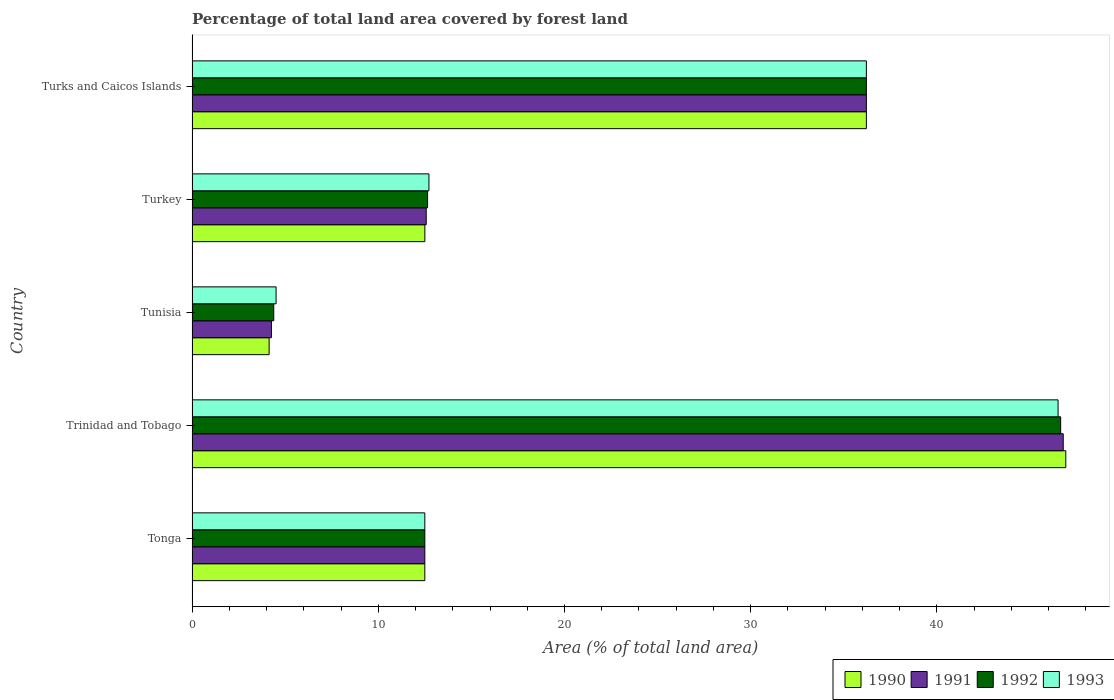How many groups of bars are there?
Give a very brief answer. 5. Are the number of bars per tick equal to the number of legend labels?
Your answer should be very brief. Yes. How many bars are there on the 4th tick from the top?
Keep it short and to the point. 4. What is the label of the 4th group of bars from the top?
Your answer should be compact. Trinidad and Tobago. Across all countries, what is the maximum percentage of forest land in 1992?
Your answer should be very brief. 46.64. Across all countries, what is the minimum percentage of forest land in 1993?
Provide a succinct answer. 4.51. In which country was the percentage of forest land in 1992 maximum?
Keep it short and to the point. Trinidad and Tobago. In which country was the percentage of forest land in 1990 minimum?
Your response must be concise. Tunisia. What is the total percentage of forest land in 1993 in the graph?
Give a very brief answer. 112.45. What is the difference between the percentage of forest land in 1993 in Tunisia and that in Turks and Caicos Islands?
Your answer should be very brief. -31.7. What is the difference between the percentage of forest land in 1991 in Tunisia and the percentage of forest land in 1992 in Tonga?
Your answer should be very brief. -8.24. What is the average percentage of forest land in 1991 per country?
Offer a terse response. 22.47. What is the difference between the percentage of forest land in 1992 and percentage of forest land in 1993 in Turkey?
Give a very brief answer. -0.07. In how many countries, is the percentage of forest land in 1990 greater than 18 %?
Offer a very short reply. 2. What is the ratio of the percentage of forest land in 1991 in Tunisia to that in Turkey?
Provide a short and direct response. 0.34. What is the difference between the highest and the second highest percentage of forest land in 1992?
Give a very brief answer. 10.43. What is the difference between the highest and the lowest percentage of forest land in 1993?
Provide a short and direct response. 41.99. In how many countries, is the percentage of forest land in 1992 greater than the average percentage of forest land in 1992 taken over all countries?
Offer a terse response. 2. Is the sum of the percentage of forest land in 1990 in Tunisia and Turks and Caicos Islands greater than the maximum percentage of forest land in 1992 across all countries?
Make the answer very short. No. Is it the case that in every country, the sum of the percentage of forest land in 1993 and percentage of forest land in 1990 is greater than the sum of percentage of forest land in 1991 and percentage of forest land in 1992?
Offer a very short reply. No. Is it the case that in every country, the sum of the percentage of forest land in 1990 and percentage of forest land in 1992 is greater than the percentage of forest land in 1991?
Your answer should be very brief. Yes. How many countries are there in the graph?
Your answer should be very brief. 5. What is the difference between two consecutive major ticks on the X-axis?
Offer a terse response. 10. Are the values on the major ticks of X-axis written in scientific E-notation?
Ensure brevity in your answer.  No. Does the graph contain grids?
Your response must be concise. No. Where does the legend appear in the graph?
Your answer should be very brief. Bottom right. How many legend labels are there?
Make the answer very short. 4. How are the legend labels stacked?
Make the answer very short. Horizontal. What is the title of the graph?
Offer a very short reply. Percentage of total land area covered by forest land. What is the label or title of the X-axis?
Keep it short and to the point. Area (% of total land area). What is the label or title of the Y-axis?
Ensure brevity in your answer.  Country. What is the Area (% of total land area) in 1990 in Tonga?
Offer a terse response. 12.5. What is the Area (% of total land area) in 1991 in Tonga?
Make the answer very short. 12.5. What is the Area (% of total land area) of 1992 in Tonga?
Make the answer very short. 12.5. What is the Area (% of total land area) in 1990 in Trinidad and Tobago?
Offer a terse response. 46.92. What is the Area (% of total land area) of 1991 in Trinidad and Tobago?
Keep it short and to the point. 46.78. What is the Area (% of total land area) of 1992 in Trinidad and Tobago?
Provide a short and direct response. 46.64. What is the Area (% of total land area) of 1993 in Trinidad and Tobago?
Provide a short and direct response. 46.5. What is the Area (% of total land area) of 1990 in Tunisia?
Offer a terse response. 4.14. What is the Area (% of total land area) in 1991 in Tunisia?
Give a very brief answer. 4.26. What is the Area (% of total land area) in 1992 in Tunisia?
Provide a short and direct response. 4.39. What is the Area (% of total land area) of 1993 in Tunisia?
Provide a short and direct response. 4.51. What is the Area (% of total land area) of 1990 in Turkey?
Provide a short and direct response. 12.5. What is the Area (% of total land area) of 1991 in Turkey?
Your answer should be compact. 12.58. What is the Area (% of total land area) in 1992 in Turkey?
Your response must be concise. 12.65. What is the Area (% of total land area) in 1993 in Turkey?
Keep it short and to the point. 12.72. What is the Area (% of total land area) in 1990 in Turks and Caicos Islands?
Offer a terse response. 36.21. What is the Area (% of total land area) in 1991 in Turks and Caicos Islands?
Offer a terse response. 36.21. What is the Area (% of total land area) in 1992 in Turks and Caicos Islands?
Your answer should be very brief. 36.21. What is the Area (% of total land area) in 1993 in Turks and Caicos Islands?
Make the answer very short. 36.21. Across all countries, what is the maximum Area (% of total land area) in 1990?
Offer a terse response. 46.92. Across all countries, what is the maximum Area (% of total land area) in 1991?
Give a very brief answer. 46.78. Across all countries, what is the maximum Area (% of total land area) in 1992?
Your answer should be compact. 46.64. Across all countries, what is the maximum Area (% of total land area) of 1993?
Your response must be concise. 46.5. Across all countries, what is the minimum Area (% of total land area) in 1990?
Offer a very short reply. 4.14. Across all countries, what is the minimum Area (% of total land area) in 1991?
Provide a short and direct response. 4.26. Across all countries, what is the minimum Area (% of total land area) of 1992?
Offer a terse response. 4.39. Across all countries, what is the minimum Area (% of total land area) of 1993?
Ensure brevity in your answer.  4.51. What is the total Area (% of total land area) of 1990 in the graph?
Keep it short and to the point. 112.27. What is the total Area (% of total land area) in 1991 in the graph?
Ensure brevity in your answer.  112.33. What is the total Area (% of total land area) of 1992 in the graph?
Offer a very short reply. 112.39. What is the total Area (% of total land area) of 1993 in the graph?
Your response must be concise. 112.45. What is the difference between the Area (% of total land area) in 1990 in Tonga and that in Trinidad and Tobago?
Provide a short and direct response. -34.42. What is the difference between the Area (% of total land area) of 1991 in Tonga and that in Trinidad and Tobago?
Give a very brief answer. -34.28. What is the difference between the Area (% of total land area) of 1992 in Tonga and that in Trinidad and Tobago?
Your answer should be compact. -34.14. What is the difference between the Area (% of total land area) of 1993 in Tonga and that in Trinidad and Tobago?
Keep it short and to the point. -34. What is the difference between the Area (% of total land area) in 1990 in Tonga and that in Tunisia?
Ensure brevity in your answer.  8.36. What is the difference between the Area (% of total land area) of 1991 in Tonga and that in Tunisia?
Keep it short and to the point. 8.24. What is the difference between the Area (% of total land area) in 1992 in Tonga and that in Tunisia?
Ensure brevity in your answer.  8.11. What is the difference between the Area (% of total land area) of 1993 in Tonga and that in Tunisia?
Ensure brevity in your answer.  7.99. What is the difference between the Area (% of total land area) in 1990 in Tonga and that in Turkey?
Ensure brevity in your answer.  -0. What is the difference between the Area (% of total land area) in 1991 in Tonga and that in Turkey?
Your answer should be compact. -0.07. What is the difference between the Area (% of total land area) in 1992 in Tonga and that in Turkey?
Provide a short and direct response. -0.15. What is the difference between the Area (% of total land area) of 1993 in Tonga and that in Turkey?
Offer a terse response. -0.22. What is the difference between the Area (% of total land area) in 1990 in Tonga and that in Turks and Caicos Islands?
Provide a short and direct response. -23.71. What is the difference between the Area (% of total land area) of 1991 in Tonga and that in Turks and Caicos Islands?
Provide a short and direct response. -23.71. What is the difference between the Area (% of total land area) of 1992 in Tonga and that in Turks and Caicos Islands?
Your response must be concise. -23.71. What is the difference between the Area (% of total land area) in 1993 in Tonga and that in Turks and Caicos Islands?
Your answer should be compact. -23.71. What is the difference between the Area (% of total land area) in 1990 in Trinidad and Tobago and that in Tunisia?
Offer a terse response. 42.78. What is the difference between the Area (% of total land area) of 1991 in Trinidad and Tobago and that in Tunisia?
Your answer should be very brief. 42.52. What is the difference between the Area (% of total land area) in 1992 in Trinidad and Tobago and that in Tunisia?
Your answer should be compact. 42.25. What is the difference between the Area (% of total land area) of 1993 in Trinidad and Tobago and that in Tunisia?
Ensure brevity in your answer.  41.99. What is the difference between the Area (% of total land area) in 1990 in Trinidad and Tobago and that in Turkey?
Offer a terse response. 34.42. What is the difference between the Area (% of total land area) in 1991 in Trinidad and Tobago and that in Turkey?
Your response must be concise. 34.21. What is the difference between the Area (% of total land area) in 1992 in Trinidad and Tobago and that in Turkey?
Provide a succinct answer. 34. What is the difference between the Area (% of total land area) of 1993 in Trinidad and Tobago and that in Turkey?
Your answer should be very brief. 33.78. What is the difference between the Area (% of total land area) of 1990 in Trinidad and Tobago and that in Turks and Caicos Islands?
Keep it short and to the point. 10.71. What is the difference between the Area (% of total land area) in 1991 in Trinidad and Tobago and that in Turks and Caicos Islands?
Ensure brevity in your answer.  10.57. What is the difference between the Area (% of total land area) in 1992 in Trinidad and Tobago and that in Turks and Caicos Islands?
Your answer should be compact. 10.43. What is the difference between the Area (% of total land area) of 1993 in Trinidad and Tobago and that in Turks and Caicos Islands?
Your answer should be very brief. 10.29. What is the difference between the Area (% of total land area) of 1990 in Tunisia and that in Turkey?
Your answer should be compact. -8.36. What is the difference between the Area (% of total land area) of 1991 in Tunisia and that in Turkey?
Give a very brief answer. -8.31. What is the difference between the Area (% of total land area) in 1992 in Tunisia and that in Turkey?
Your response must be concise. -8.26. What is the difference between the Area (% of total land area) in 1993 in Tunisia and that in Turkey?
Offer a terse response. -8.21. What is the difference between the Area (% of total land area) in 1990 in Tunisia and that in Turks and Caicos Islands?
Provide a short and direct response. -32.07. What is the difference between the Area (% of total land area) in 1991 in Tunisia and that in Turks and Caicos Islands?
Ensure brevity in your answer.  -31.95. What is the difference between the Area (% of total land area) in 1992 in Tunisia and that in Turks and Caicos Islands?
Keep it short and to the point. -31.82. What is the difference between the Area (% of total land area) in 1993 in Tunisia and that in Turks and Caicos Islands?
Your answer should be compact. -31.7. What is the difference between the Area (% of total land area) of 1990 in Turkey and that in Turks and Caicos Islands?
Your answer should be compact. -23.71. What is the difference between the Area (% of total land area) in 1991 in Turkey and that in Turks and Caicos Islands?
Your response must be concise. -23.64. What is the difference between the Area (% of total land area) in 1992 in Turkey and that in Turks and Caicos Islands?
Offer a terse response. -23.56. What is the difference between the Area (% of total land area) in 1993 in Turkey and that in Turks and Caicos Islands?
Your response must be concise. -23.49. What is the difference between the Area (% of total land area) in 1990 in Tonga and the Area (% of total land area) in 1991 in Trinidad and Tobago?
Your answer should be very brief. -34.28. What is the difference between the Area (% of total land area) of 1990 in Tonga and the Area (% of total land area) of 1992 in Trinidad and Tobago?
Make the answer very short. -34.14. What is the difference between the Area (% of total land area) in 1990 in Tonga and the Area (% of total land area) in 1993 in Trinidad and Tobago?
Your answer should be compact. -34. What is the difference between the Area (% of total land area) of 1991 in Tonga and the Area (% of total land area) of 1992 in Trinidad and Tobago?
Give a very brief answer. -34.14. What is the difference between the Area (% of total land area) in 1991 in Tonga and the Area (% of total land area) in 1993 in Trinidad and Tobago?
Give a very brief answer. -34. What is the difference between the Area (% of total land area) in 1992 in Tonga and the Area (% of total land area) in 1993 in Trinidad and Tobago?
Make the answer very short. -34. What is the difference between the Area (% of total land area) of 1990 in Tonga and the Area (% of total land area) of 1991 in Tunisia?
Provide a succinct answer. 8.24. What is the difference between the Area (% of total land area) of 1990 in Tonga and the Area (% of total land area) of 1992 in Tunisia?
Offer a terse response. 8.11. What is the difference between the Area (% of total land area) in 1990 in Tonga and the Area (% of total land area) in 1993 in Tunisia?
Make the answer very short. 7.99. What is the difference between the Area (% of total land area) of 1991 in Tonga and the Area (% of total land area) of 1992 in Tunisia?
Ensure brevity in your answer.  8.11. What is the difference between the Area (% of total land area) in 1991 in Tonga and the Area (% of total land area) in 1993 in Tunisia?
Your answer should be compact. 7.99. What is the difference between the Area (% of total land area) of 1992 in Tonga and the Area (% of total land area) of 1993 in Tunisia?
Provide a short and direct response. 7.99. What is the difference between the Area (% of total land area) of 1990 in Tonga and the Area (% of total land area) of 1991 in Turkey?
Ensure brevity in your answer.  -0.07. What is the difference between the Area (% of total land area) of 1990 in Tonga and the Area (% of total land area) of 1992 in Turkey?
Give a very brief answer. -0.15. What is the difference between the Area (% of total land area) of 1990 in Tonga and the Area (% of total land area) of 1993 in Turkey?
Ensure brevity in your answer.  -0.22. What is the difference between the Area (% of total land area) in 1991 in Tonga and the Area (% of total land area) in 1992 in Turkey?
Give a very brief answer. -0.15. What is the difference between the Area (% of total land area) in 1991 in Tonga and the Area (% of total land area) in 1993 in Turkey?
Keep it short and to the point. -0.22. What is the difference between the Area (% of total land area) in 1992 in Tonga and the Area (% of total land area) in 1993 in Turkey?
Offer a very short reply. -0.22. What is the difference between the Area (% of total land area) in 1990 in Tonga and the Area (% of total land area) in 1991 in Turks and Caicos Islands?
Ensure brevity in your answer.  -23.71. What is the difference between the Area (% of total land area) in 1990 in Tonga and the Area (% of total land area) in 1992 in Turks and Caicos Islands?
Provide a short and direct response. -23.71. What is the difference between the Area (% of total land area) of 1990 in Tonga and the Area (% of total land area) of 1993 in Turks and Caicos Islands?
Offer a terse response. -23.71. What is the difference between the Area (% of total land area) of 1991 in Tonga and the Area (% of total land area) of 1992 in Turks and Caicos Islands?
Your answer should be very brief. -23.71. What is the difference between the Area (% of total land area) in 1991 in Tonga and the Area (% of total land area) in 1993 in Turks and Caicos Islands?
Give a very brief answer. -23.71. What is the difference between the Area (% of total land area) in 1992 in Tonga and the Area (% of total land area) in 1993 in Turks and Caicos Islands?
Provide a succinct answer. -23.71. What is the difference between the Area (% of total land area) in 1990 in Trinidad and Tobago and the Area (% of total land area) in 1991 in Tunisia?
Offer a terse response. 42.66. What is the difference between the Area (% of total land area) of 1990 in Trinidad and Tobago and the Area (% of total land area) of 1992 in Tunisia?
Ensure brevity in your answer.  42.53. What is the difference between the Area (% of total land area) in 1990 in Trinidad and Tobago and the Area (% of total land area) in 1993 in Tunisia?
Offer a very short reply. 42.41. What is the difference between the Area (% of total land area) of 1991 in Trinidad and Tobago and the Area (% of total land area) of 1992 in Tunisia?
Provide a short and direct response. 42.39. What is the difference between the Area (% of total land area) of 1991 in Trinidad and Tobago and the Area (% of total land area) of 1993 in Tunisia?
Your answer should be very brief. 42.27. What is the difference between the Area (% of total land area) in 1992 in Trinidad and Tobago and the Area (% of total land area) in 1993 in Tunisia?
Give a very brief answer. 42.13. What is the difference between the Area (% of total land area) in 1990 in Trinidad and Tobago and the Area (% of total land area) in 1991 in Turkey?
Your answer should be compact. 34.35. What is the difference between the Area (% of total land area) of 1990 in Trinidad and Tobago and the Area (% of total land area) of 1992 in Turkey?
Your response must be concise. 34.27. What is the difference between the Area (% of total land area) in 1990 in Trinidad and Tobago and the Area (% of total land area) in 1993 in Turkey?
Make the answer very short. 34.2. What is the difference between the Area (% of total land area) of 1991 in Trinidad and Tobago and the Area (% of total land area) of 1992 in Turkey?
Ensure brevity in your answer.  34.13. What is the difference between the Area (% of total land area) in 1991 in Trinidad and Tobago and the Area (% of total land area) in 1993 in Turkey?
Give a very brief answer. 34.06. What is the difference between the Area (% of total land area) of 1992 in Trinidad and Tobago and the Area (% of total land area) of 1993 in Turkey?
Offer a terse response. 33.92. What is the difference between the Area (% of total land area) in 1990 in Trinidad and Tobago and the Area (% of total land area) in 1991 in Turks and Caicos Islands?
Offer a terse response. 10.71. What is the difference between the Area (% of total land area) in 1990 in Trinidad and Tobago and the Area (% of total land area) in 1992 in Turks and Caicos Islands?
Ensure brevity in your answer.  10.71. What is the difference between the Area (% of total land area) of 1990 in Trinidad and Tobago and the Area (% of total land area) of 1993 in Turks and Caicos Islands?
Your answer should be compact. 10.71. What is the difference between the Area (% of total land area) of 1991 in Trinidad and Tobago and the Area (% of total land area) of 1992 in Turks and Caicos Islands?
Offer a terse response. 10.57. What is the difference between the Area (% of total land area) in 1991 in Trinidad and Tobago and the Area (% of total land area) in 1993 in Turks and Caicos Islands?
Your answer should be very brief. 10.57. What is the difference between the Area (% of total land area) of 1992 in Trinidad and Tobago and the Area (% of total land area) of 1993 in Turks and Caicos Islands?
Give a very brief answer. 10.43. What is the difference between the Area (% of total land area) in 1990 in Tunisia and the Area (% of total land area) in 1991 in Turkey?
Provide a succinct answer. -8.44. What is the difference between the Area (% of total land area) in 1990 in Tunisia and the Area (% of total land area) in 1992 in Turkey?
Make the answer very short. -8.51. What is the difference between the Area (% of total land area) in 1990 in Tunisia and the Area (% of total land area) in 1993 in Turkey?
Give a very brief answer. -8.58. What is the difference between the Area (% of total land area) in 1991 in Tunisia and the Area (% of total land area) in 1992 in Turkey?
Provide a succinct answer. -8.38. What is the difference between the Area (% of total land area) in 1991 in Tunisia and the Area (% of total land area) in 1993 in Turkey?
Offer a terse response. -8.46. What is the difference between the Area (% of total land area) of 1992 in Tunisia and the Area (% of total land area) of 1993 in Turkey?
Make the answer very short. -8.33. What is the difference between the Area (% of total land area) in 1990 in Tunisia and the Area (% of total land area) in 1991 in Turks and Caicos Islands?
Keep it short and to the point. -32.07. What is the difference between the Area (% of total land area) in 1990 in Tunisia and the Area (% of total land area) in 1992 in Turks and Caicos Islands?
Keep it short and to the point. -32.07. What is the difference between the Area (% of total land area) in 1990 in Tunisia and the Area (% of total land area) in 1993 in Turks and Caicos Islands?
Keep it short and to the point. -32.07. What is the difference between the Area (% of total land area) in 1991 in Tunisia and the Area (% of total land area) in 1992 in Turks and Caicos Islands?
Your response must be concise. -31.95. What is the difference between the Area (% of total land area) of 1991 in Tunisia and the Area (% of total land area) of 1993 in Turks and Caicos Islands?
Offer a very short reply. -31.95. What is the difference between the Area (% of total land area) of 1992 in Tunisia and the Area (% of total land area) of 1993 in Turks and Caicos Islands?
Ensure brevity in your answer.  -31.82. What is the difference between the Area (% of total land area) in 1990 in Turkey and the Area (% of total land area) in 1991 in Turks and Caicos Islands?
Provide a succinct answer. -23.71. What is the difference between the Area (% of total land area) in 1990 in Turkey and the Area (% of total land area) in 1992 in Turks and Caicos Islands?
Keep it short and to the point. -23.71. What is the difference between the Area (% of total land area) of 1990 in Turkey and the Area (% of total land area) of 1993 in Turks and Caicos Islands?
Provide a succinct answer. -23.71. What is the difference between the Area (% of total land area) in 1991 in Turkey and the Area (% of total land area) in 1992 in Turks and Caicos Islands?
Your response must be concise. -23.64. What is the difference between the Area (% of total land area) of 1991 in Turkey and the Area (% of total land area) of 1993 in Turks and Caicos Islands?
Provide a short and direct response. -23.64. What is the difference between the Area (% of total land area) in 1992 in Turkey and the Area (% of total land area) in 1993 in Turks and Caicos Islands?
Provide a succinct answer. -23.56. What is the average Area (% of total land area) of 1990 per country?
Provide a short and direct response. 22.45. What is the average Area (% of total land area) in 1991 per country?
Ensure brevity in your answer.  22.47. What is the average Area (% of total land area) of 1992 per country?
Make the answer very short. 22.48. What is the average Area (% of total land area) in 1993 per country?
Your answer should be very brief. 22.49. What is the difference between the Area (% of total land area) of 1991 and Area (% of total land area) of 1992 in Tonga?
Your answer should be compact. 0. What is the difference between the Area (% of total land area) of 1990 and Area (% of total land area) of 1991 in Trinidad and Tobago?
Provide a short and direct response. 0.14. What is the difference between the Area (% of total land area) of 1990 and Area (% of total land area) of 1992 in Trinidad and Tobago?
Offer a very short reply. 0.28. What is the difference between the Area (% of total land area) in 1990 and Area (% of total land area) in 1993 in Trinidad and Tobago?
Keep it short and to the point. 0.42. What is the difference between the Area (% of total land area) of 1991 and Area (% of total land area) of 1992 in Trinidad and Tobago?
Your answer should be very brief. 0.14. What is the difference between the Area (% of total land area) of 1991 and Area (% of total land area) of 1993 in Trinidad and Tobago?
Provide a short and direct response. 0.28. What is the difference between the Area (% of total land area) in 1992 and Area (% of total land area) in 1993 in Trinidad and Tobago?
Your response must be concise. 0.14. What is the difference between the Area (% of total land area) in 1990 and Area (% of total land area) in 1991 in Tunisia?
Offer a terse response. -0.12. What is the difference between the Area (% of total land area) of 1990 and Area (% of total land area) of 1992 in Tunisia?
Provide a short and direct response. -0.25. What is the difference between the Area (% of total land area) of 1990 and Area (% of total land area) of 1993 in Tunisia?
Your response must be concise. -0.37. What is the difference between the Area (% of total land area) of 1991 and Area (% of total land area) of 1992 in Tunisia?
Offer a very short reply. -0.12. What is the difference between the Area (% of total land area) of 1991 and Area (% of total land area) of 1993 in Tunisia?
Your response must be concise. -0.25. What is the difference between the Area (% of total land area) in 1992 and Area (% of total land area) in 1993 in Tunisia?
Your response must be concise. -0.12. What is the difference between the Area (% of total land area) in 1990 and Area (% of total land area) in 1991 in Turkey?
Offer a very short reply. -0.07. What is the difference between the Area (% of total land area) of 1990 and Area (% of total land area) of 1992 in Turkey?
Provide a succinct answer. -0.15. What is the difference between the Area (% of total land area) of 1990 and Area (% of total land area) of 1993 in Turkey?
Your answer should be very brief. -0.22. What is the difference between the Area (% of total land area) of 1991 and Area (% of total land area) of 1992 in Turkey?
Keep it short and to the point. -0.07. What is the difference between the Area (% of total land area) of 1991 and Area (% of total land area) of 1993 in Turkey?
Offer a terse response. -0.15. What is the difference between the Area (% of total land area) of 1992 and Area (% of total land area) of 1993 in Turkey?
Offer a terse response. -0.07. What is the difference between the Area (% of total land area) in 1990 and Area (% of total land area) in 1991 in Turks and Caicos Islands?
Your answer should be very brief. 0. What is the difference between the Area (% of total land area) in 1990 and Area (% of total land area) in 1992 in Turks and Caicos Islands?
Your response must be concise. 0. What is the difference between the Area (% of total land area) of 1990 and Area (% of total land area) of 1993 in Turks and Caicos Islands?
Ensure brevity in your answer.  0. What is the difference between the Area (% of total land area) in 1991 and Area (% of total land area) in 1992 in Turks and Caicos Islands?
Give a very brief answer. 0. What is the ratio of the Area (% of total land area) in 1990 in Tonga to that in Trinidad and Tobago?
Your answer should be very brief. 0.27. What is the ratio of the Area (% of total land area) in 1991 in Tonga to that in Trinidad and Tobago?
Your answer should be compact. 0.27. What is the ratio of the Area (% of total land area) in 1992 in Tonga to that in Trinidad and Tobago?
Offer a very short reply. 0.27. What is the ratio of the Area (% of total land area) of 1993 in Tonga to that in Trinidad and Tobago?
Give a very brief answer. 0.27. What is the ratio of the Area (% of total land area) of 1990 in Tonga to that in Tunisia?
Offer a very short reply. 3.02. What is the ratio of the Area (% of total land area) in 1991 in Tonga to that in Tunisia?
Make the answer very short. 2.93. What is the ratio of the Area (% of total land area) of 1992 in Tonga to that in Tunisia?
Provide a succinct answer. 2.85. What is the ratio of the Area (% of total land area) in 1993 in Tonga to that in Tunisia?
Provide a short and direct response. 2.77. What is the ratio of the Area (% of total land area) of 1991 in Tonga to that in Turkey?
Provide a short and direct response. 0.99. What is the ratio of the Area (% of total land area) in 1992 in Tonga to that in Turkey?
Ensure brevity in your answer.  0.99. What is the ratio of the Area (% of total land area) in 1993 in Tonga to that in Turkey?
Provide a succinct answer. 0.98. What is the ratio of the Area (% of total land area) in 1990 in Tonga to that in Turks and Caicos Islands?
Offer a terse response. 0.35. What is the ratio of the Area (% of total land area) in 1991 in Tonga to that in Turks and Caicos Islands?
Your response must be concise. 0.35. What is the ratio of the Area (% of total land area) of 1992 in Tonga to that in Turks and Caicos Islands?
Keep it short and to the point. 0.35. What is the ratio of the Area (% of total land area) of 1993 in Tonga to that in Turks and Caicos Islands?
Your response must be concise. 0.35. What is the ratio of the Area (% of total land area) of 1990 in Trinidad and Tobago to that in Tunisia?
Your response must be concise. 11.34. What is the ratio of the Area (% of total land area) of 1991 in Trinidad and Tobago to that in Tunisia?
Your answer should be compact. 10.97. What is the ratio of the Area (% of total land area) in 1992 in Trinidad and Tobago to that in Tunisia?
Your response must be concise. 10.63. What is the ratio of the Area (% of total land area) of 1993 in Trinidad and Tobago to that in Tunisia?
Your answer should be very brief. 10.3. What is the ratio of the Area (% of total land area) of 1990 in Trinidad and Tobago to that in Turkey?
Ensure brevity in your answer.  3.75. What is the ratio of the Area (% of total land area) in 1991 in Trinidad and Tobago to that in Turkey?
Give a very brief answer. 3.72. What is the ratio of the Area (% of total land area) in 1992 in Trinidad and Tobago to that in Turkey?
Keep it short and to the point. 3.69. What is the ratio of the Area (% of total land area) of 1993 in Trinidad and Tobago to that in Turkey?
Provide a succinct answer. 3.66. What is the ratio of the Area (% of total land area) in 1990 in Trinidad and Tobago to that in Turks and Caicos Islands?
Keep it short and to the point. 1.3. What is the ratio of the Area (% of total land area) of 1991 in Trinidad and Tobago to that in Turks and Caicos Islands?
Ensure brevity in your answer.  1.29. What is the ratio of the Area (% of total land area) in 1992 in Trinidad and Tobago to that in Turks and Caicos Islands?
Keep it short and to the point. 1.29. What is the ratio of the Area (% of total land area) of 1993 in Trinidad and Tobago to that in Turks and Caicos Islands?
Provide a short and direct response. 1.28. What is the ratio of the Area (% of total land area) of 1990 in Tunisia to that in Turkey?
Offer a very short reply. 0.33. What is the ratio of the Area (% of total land area) in 1991 in Tunisia to that in Turkey?
Your answer should be compact. 0.34. What is the ratio of the Area (% of total land area) in 1992 in Tunisia to that in Turkey?
Your answer should be very brief. 0.35. What is the ratio of the Area (% of total land area) of 1993 in Tunisia to that in Turkey?
Ensure brevity in your answer.  0.35. What is the ratio of the Area (% of total land area) of 1990 in Tunisia to that in Turks and Caicos Islands?
Give a very brief answer. 0.11. What is the ratio of the Area (% of total land area) in 1991 in Tunisia to that in Turks and Caicos Islands?
Your answer should be compact. 0.12. What is the ratio of the Area (% of total land area) in 1992 in Tunisia to that in Turks and Caicos Islands?
Offer a terse response. 0.12. What is the ratio of the Area (% of total land area) of 1993 in Tunisia to that in Turks and Caicos Islands?
Offer a terse response. 0.12. What is the ratio of the Area (% of total land area) in 1990 in Turkey to that in Turks and Caicos Islands?
Your answer should be very brief. 0.35. What is the ratio of the Area (% of total land area) in 1991 in Turkey to that in Turks and Caicos Islands?
Provide a succinct answer. 0.35. What is the ratio of the Area (% of total land area) of 1992 in Turkey to that in Turks and Caicos Islands?
Offer a terse response. 0.35. What is the ratio of the Area (% of total land area) in 1993 in Turkey to that in Turks and Caicos Islands?
Your response must be concise. 0.35. What is the difference between the highest and the second highest Area (% of total land area) in 1990?
Your answer should be compact. 10.71. What is the difference between the highest and the second highest Area (% of total land area) of 1991?
Provide a succinct answer. 10.57. What is the difference between the highest and the second highest Area (% of total land area) of 1992?
Offer a terse response. 10.43. What is the difference between the highest and the second highest Area (% of total land area) of 1993?
Provide a short and direct response. 10.29. What is the difference between the highest and the lowest Area (% of total land area) in 1990?
Provide a succinct answer. 42.78. What is the difference between the highest and the lowest Area (% of total land area) of 1991?
Keep it short and to the point. 42.52. What is the difference between the highest and the lowest Area (% of total land area) in 1992?
Your answer should be compact. 42.25. What is the difference between the highest and the lowest Area (% of total land area) in 1993?
Give a very brief answer. 41.99. 